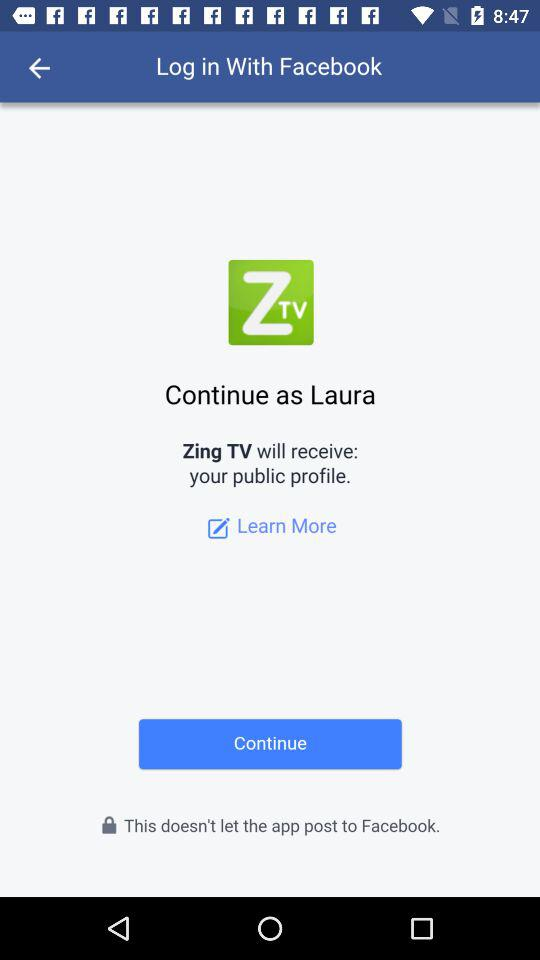What application has received the public profile? The application that has received a public profile is "Zing TV". 